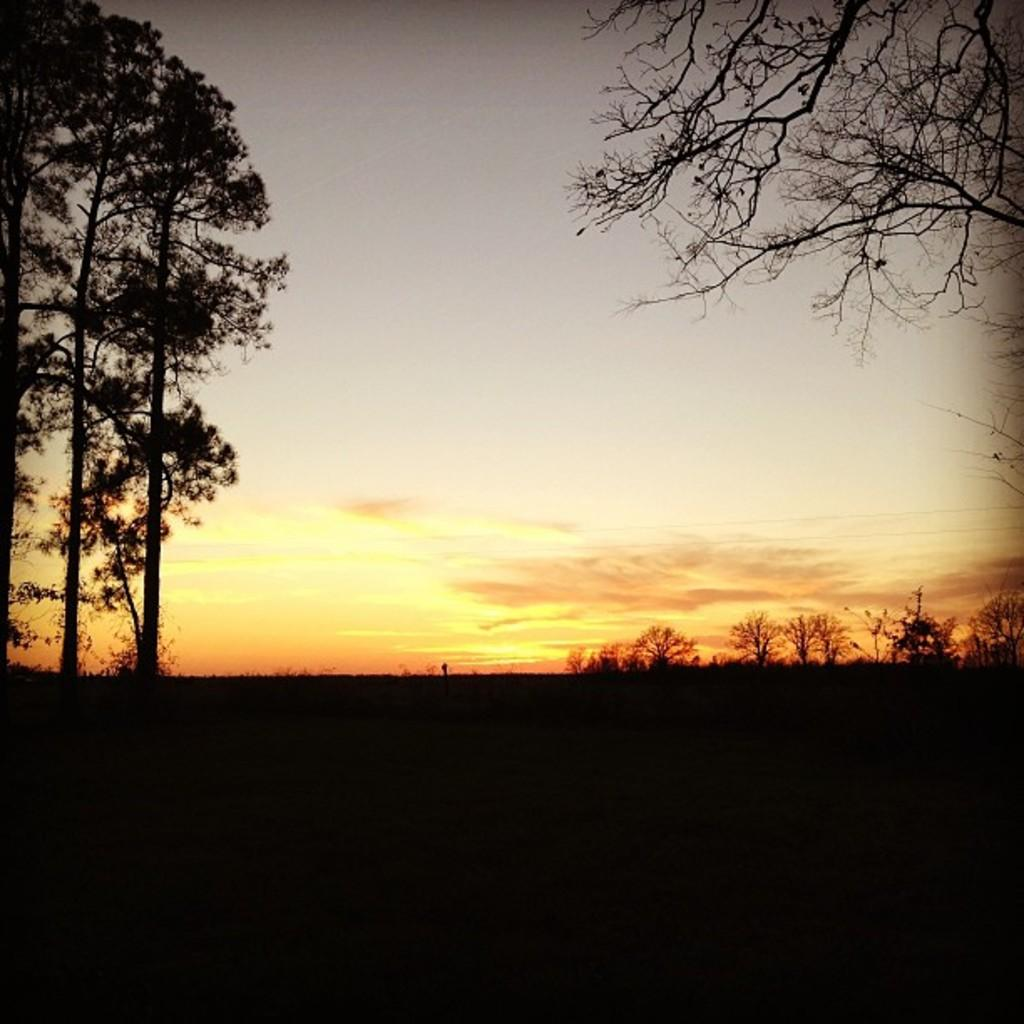What type of vegetation can be seen in the image? There is grass and trees in the image. What part of the natural environment is visible in the image? The sky is visible in the image. How might the image have been captured? The image may have been taken from the ground. How many toes can be seen in the image? There are no toes visible in the image; it features grass, trees, and the sky. 